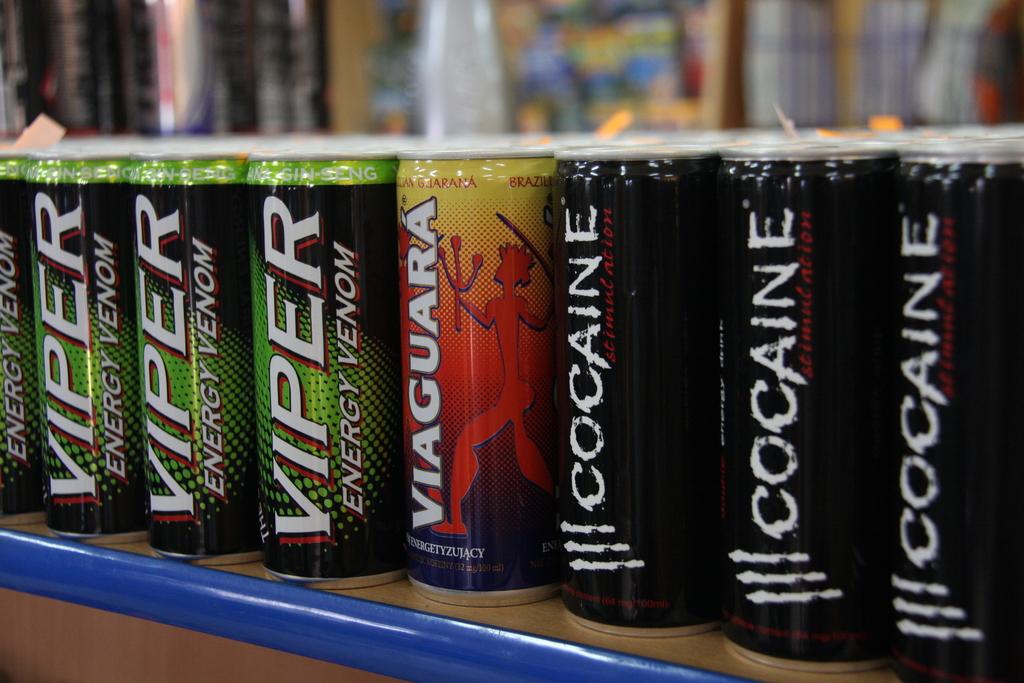What brand drink is energy venom?
Ensure brevity in your answer.  Viper. What is written sideways on the black can?
Make the answer very short. Cocaine. 